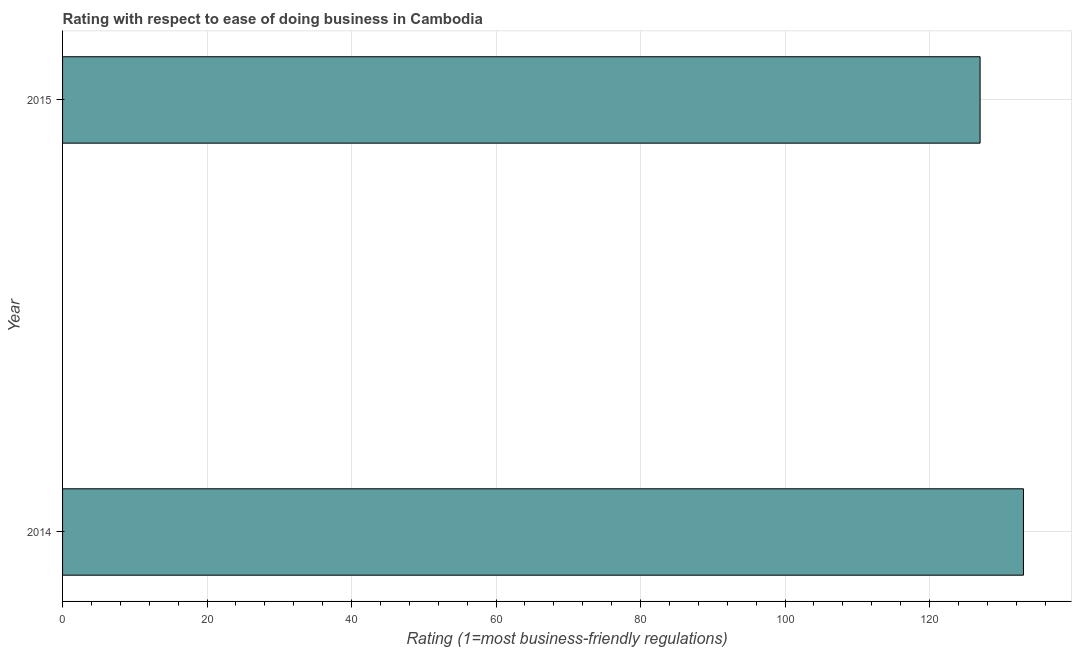Does the graph contain any zero values?
Your answer should be very brief. No. What is the title of the graph?
Give a very brief answer. Rating with respect to ease of doing business in Cambodia. What is the label or title of the X-axis?
Provide a short and direct response. Rating (1=most business-friendly regulations). What is the ease of doing business index in 2014?
Your answer should be compact. 133. Across all years, what is the maximum ease of doing business index?
Ensure brevity in your answer.  133. Across all years, what is the minimum ease of doing business index?
Provide a short and direct response. 127. In which year was the ease of doing business index minimum?
Your answer should be very brief. 2015. What is the sum of the ease of doing business index?
Your answer should be very brief. 260. What is the difference between the ease of doing business index in 2014 and 2015?
Ensure brevity in your answer.  6. What is the average ease of doing business index per year?
Keep it short and to the point. 130. What is the median ease of doing business index?
Offer a very short reply. 130. What is the ratio of the ease of doing business index in 2014 to that in 2015?
Your response must be concise. 1.05. Is the ease of doing business index in 2014 less than that in 2015?
Make the answer very short. No. Are all the bars in the graph horizontal?
Keep it short and to the point. Yes. Are the values on the major ticks of X-axis written in scientific E-notation?
Ensure brevity in your answer.  No. What is the Rating (1=most business-friendly regulations) of 2014?
Offer a terse response. 133. What is the Rating (1=most business-friendly regulations) in 2015?
Provide a succinct answer. 127. What is the ratio of the Rating (1=most business-friendly regulations) in 2014 to that in 2015?
Keep it short and to the point. 1.05. 